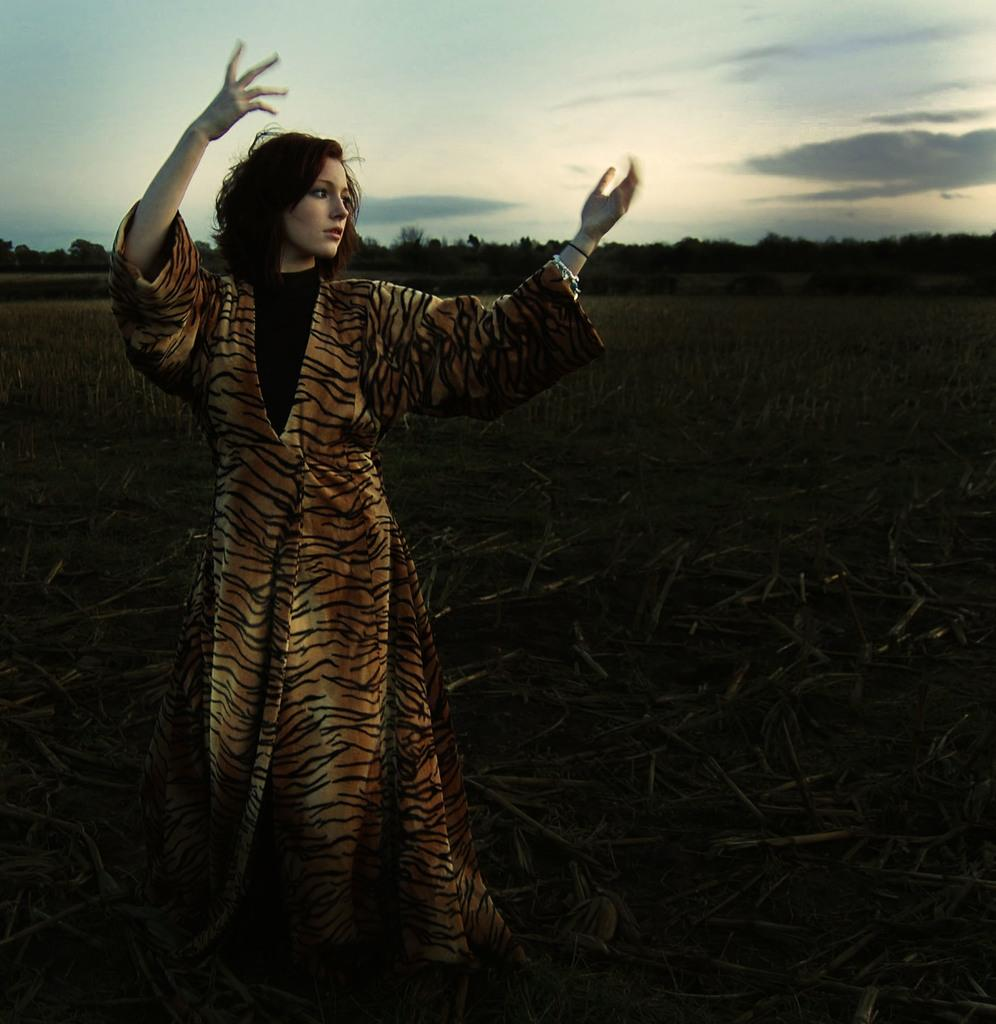Who is the main subject in the foreground of the picture? There is a woman in the foreground of the picture. What is the lighting condition in the foreground of the image? The foreground is dark. What can be seen in the background of the picture? There are trees and fields in the background of the picture. What is visible at the top of the image? The sky is visible at the top of the image. Can you see a squirrel running across the room in the image? There is no room or squirrel present in the image. Is the woman in the image exploring space? There is no indication of space exploration in the image, as it features a woman in a foreground with trees and fields in the background. 